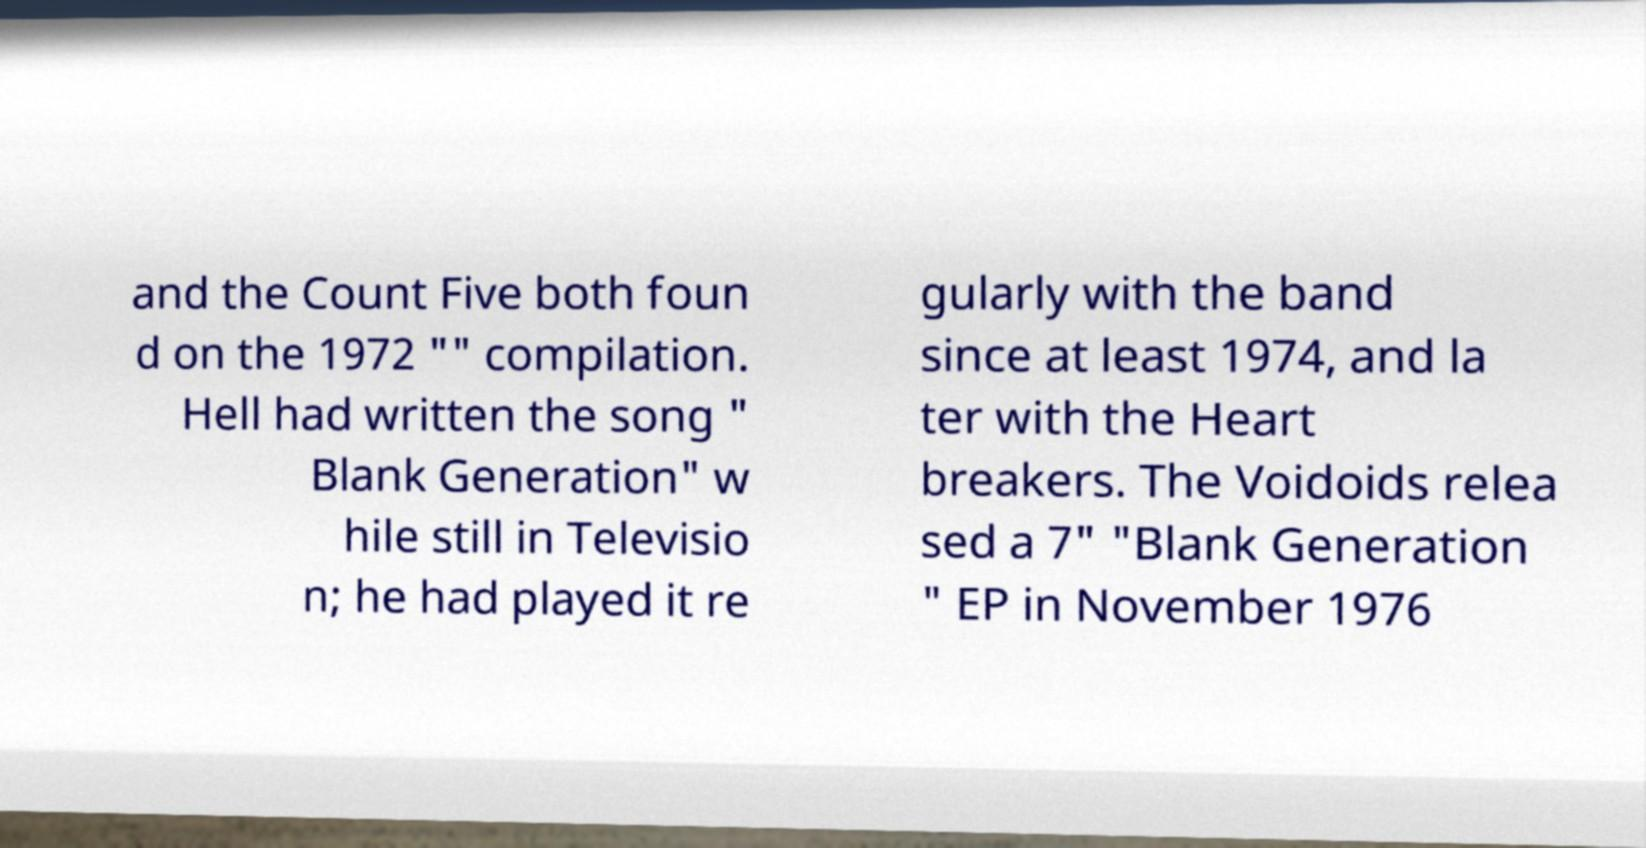Could you extract and type out the text from this image? and the Count Five both foun d on the 1972 "" compilation. Hell had written the song " Blank Generation" w hile still in Televisio n; he had played it re gularly with the band since at least 1974, and la ter with the Heart breakers. The Voidoids relea sed a 7" "Blank Generation " EP in November 1976 